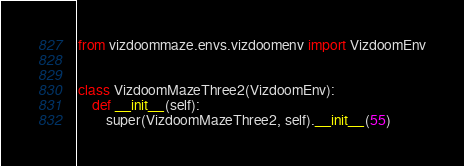<code> <loc_0><loc_0><loc_500><loc_500><_Python_>from vizdoommaze.envs.vizdoomenv import VizdoomEnv


class VizdoomMazeThree2(VizdoomEnv):
    def __init__(self):
        super(VizdoomMazeThree2, self).__init__(55)</code> 